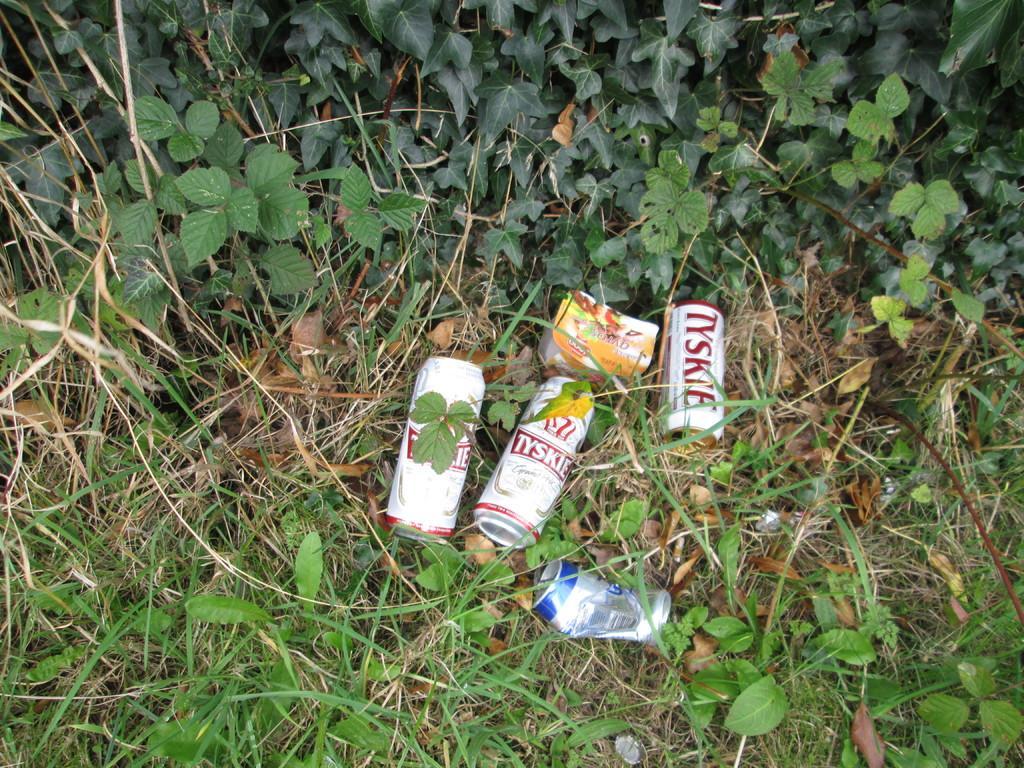Could you give a brief overview of what you see in this image? Three tins ,one bottle placed on a grass. Beside that we have a plants. 